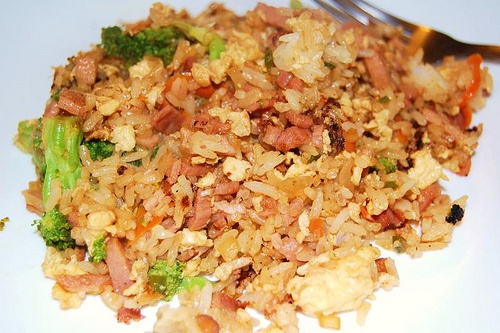Describe the objects in this image and their specific colors. I can see broccoli in lightgray, olive, and khaki tones, fork in lightgray, black, maroon, and gray tones, broccoli in lightgray, olive, darkgreen, and maroon tones, broccoli in lightgray, olive, and khaki tones, and carrot in lightgray, red, and brown tones in this image. 